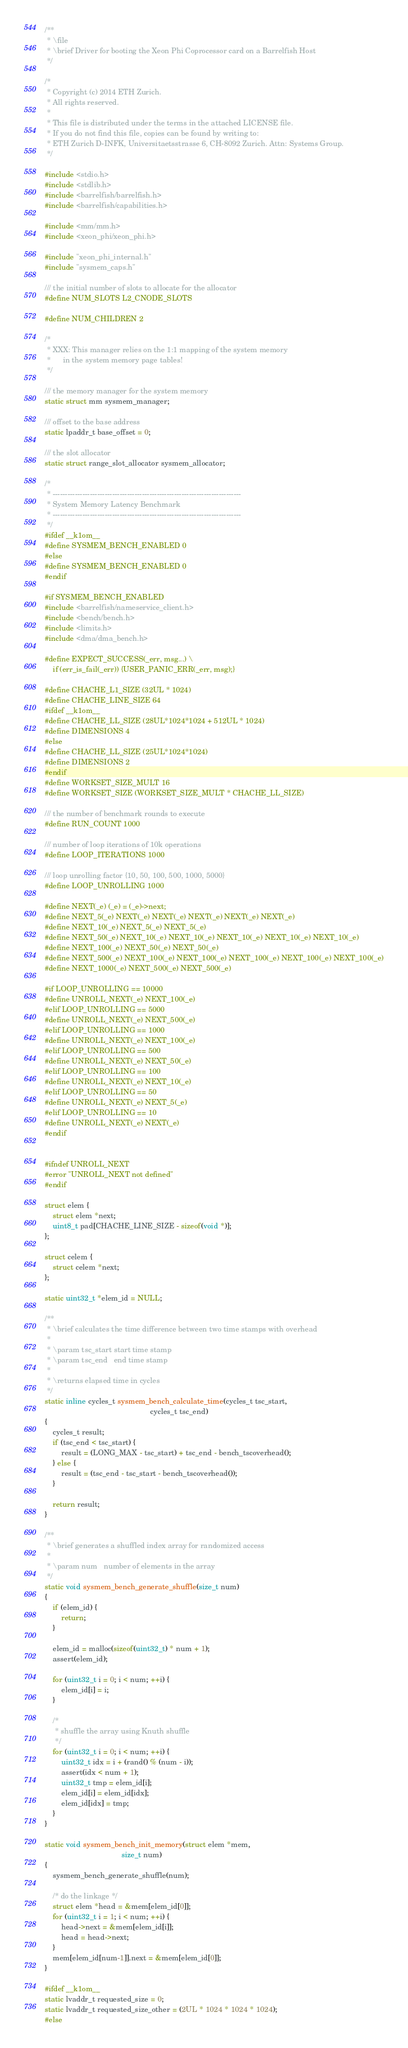Convert code to text. <code><loc_0><loc_0><loc_500><loc_500><_C_>/**
 * \file
 * \brief Driver for booting the Xeon Phi Coprocessor card on a Barrelfish Host
 */

/*
 * Copyright (c) 2014 ETH Zurich.
 * All rights reserved.
 *
 * This file is distributed under the terms in the attached LICENSE file.
 * If you do not find this file, copies can be found by writing to:
 * ETH Zurich D-INFK, Universitaetsstrasse 6, CH-8092 Zurich. Attn: Systems Group.
 */

#include <stdio.h>
#include <stdlib.h>
#include <barrelfish/barrelfish.h>
#include <barrelfish/capabilities.h>

#include <mm/mm.h>
#include <xeon_phi/xeon_phi.h>

#include "xeon_phi_internal.h"
#include "sysmem_caps.h"

/// the initial number of slots to allocate for the allocator
#define NUM_SLOTS L2_CNODE_SLOTS

#define NUM_CHILDREN 2

/*
 * XXX: This manager relies on the 1:1 mapping of the system memory
 *      in the system memory page tables!
 */

/// the memory manager for the system memory
static struct mm sysmem_manager;

/// offset to the base address
static lpaddr_t base_offset = 0;

/// the slot allocator
static struct range_slot_allocator sysmem_allocator;

/*
 * ----------------------------------------------------------------------------
 * System Memory Latency Benchmark
 * ----------------------------------------------------------------------------
 */
#ifdef __k1om__
#define SYSMEM_BENCH_ENABLED 0
#else
#define SYSMEM_BENCH_ENABLED 0
#endif

#if SYSMEM_BENCH_ENABLED
#include <barrelfish/nameservice_client.h>
#include <bench/bench.h>
#include <limits.h>
#include <dma/dma_bench.h>

#define EXPECT_SUCCESS(_err, msg...) \
    if (err_is_fail(_err)) {USER_PANIC_ERR(_err, msg);}

#define CHACHE_L1_SIZE (32UL * 1024)
#define CHACHE_LINE_SIZE 64
#ifdef __k1om__
#define CHACHE_LL_SIZE (28UL*1024*1024 + 512UL * 1024)
#define DIMENSIONS 4
#else
#define CHACHE_LL_SIZE (25UL*1024*1024)
#define DIMENSIONS 2
#endif
#define WORKSET_SIZE_MULT 16
#define WORKSET_SIZE (WORKSET_SIZE_MULT * CHACHE_LL_SIZE)

/// the number of benchmark rounds to execute
#define RUN_COUNT 1000

/// number of loop iterations of 10k operations
#define LOOP_ITERATIONS 1000

/// loop unrolling factor {10, 50, 100, 500, 1000, 5000}
#define LOOP_UNROLLING 1000

#define NEXT(_e) (_e) = (_e)->next;
#define NEXT_5(_e) NEXT(_e) NEXT(_e) NEXT(_e) NEXT(_e) NEXT(_e)
#define NEXT_10(_e) NEXT_5(_e) NEXT_5(_e)
#define NEXT_50(_e) NEXT_10(_e) NEXT_10(_e) NEXT_10(_e) NEXT_10(_e) NEXT_10(_e)
#define NEXT_100(_e) NEXT_50(_e) NEXT_50(_e)
#define NEXT_500(_e) NEXT_100(_e) NEXT_100(_e) NEXT_100(_e) NEXT_100(_e) NEXT_100(_e)
#define NEXT_1000(_e) NEXT_500(_e) NEXT_500(_e)

#if LOOP_UNROLLING == 10000
#define UNROLL_NEXT(_e) NEXT_100(_e)
#elif LOOP_UNROLLING == 5000
#define UNROLL_NEXT(_e) NEXT_500(_e)
#elif LOOP_UNROLLING == 1000
#define UNROLL_NEXT(_e) NEXT_100(_e)
#elif LOOP_UNROLLING == 500
#define UNROLL_NEXT(_e) NEXT_50(_e)
#elif LOOP_UNROLLING == 100
#define UNROLL_NEXT(_e) NEXT_10(_e)
#elif LOOP_UNROLLING == 50
#define UNROLL_NEXT(_e) NEXT_5(_e)
#elif LOOP_UNROLLING == 10
#define UNROLL_NEXT(_e) NEXT(_e)
#endif


#ifndef UNROLL_NEXT
#error "UNROLL_NEXT not defined"
#endif

struct elem {
    struct elem *next;
    uint8_t pad[CHACHE_LINE_SIZE - sizeof(void *)];
};

struct celem {
    struct celem *next;
};

static uint32_t *elem_id = NULL;

/**
 * \brief calculates the time difference between two time stamps with overhead
 *
 * \param tsc_start start time stamp
 * \param tsc_end   end time stamp
 *
 * \returns elapsed time in cycles
 */
static inline cycles_t sysmem_bench_calculate_time(cycles_t tsc_start,
                                                   cycles_t tsc_end)
{
    cycles_t result;
    if (tsc_end < tsc_start) {
        result = (LONG_MAX - tsc_start) + tsc_end - bench_tscoverhead();
    } else {
        result = (tsc_end - tsc_start - bench_tscoverhead());
    }

    return result;
}

/**
 * \brief generates a shuffled index array for randomized access
 *
 * \param num   number of elements in the array
 */
static void sysmem_bench_generate_shuffle(size_t num)
{
    if (elem_id) {
        return;
    }

    elem_id = malloc(sizeof(uint32_t) * num + 1);
    assert(elem_id);

    for (uint32_t i = 0; i < num; ++i) {
        elem_id[i] = i;
    }

    /*
     * shuffle the array using Knuth shuffle
     */
    for (uint32_t i = 0; i < num; ++i) {
        uint32_t idx = i + (rand() % (num - i));
        assert(idx < num + 1);
        uint32_t tmp = elem_id[i];
        elem_id[i] = elem_id[idx];
        elem_id[idx] = tmp;
    }
}

static void sysmem_bench_init_memory(struct elem *mem,
                                     size_t num)
{
    sysmem_bench_generate_shuffle(num);

    /* do the linkage */
    struct elem *head = &mem[elem_id[0]];
    for (uint32_t i = 1; i < num; ++i) {
        head->next = &mem[elem_id[i]];
        head = head->next;
    }
    mem[elem_id[num-1]].next = &mem[elem_id[0]];
}

#ifdef __k1om__
static lvaddr_t requested_size = 0;
static lvaddr_t requested_size_other = (2UL * 1024 * 1024 * 1024);
#else</code> 